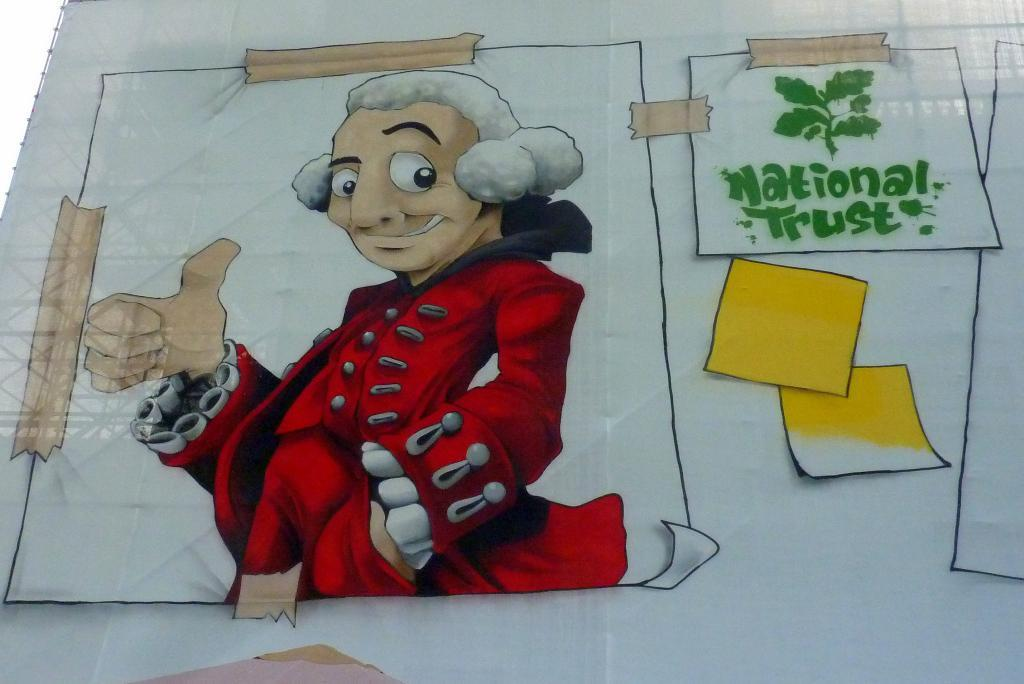<image>
Offer a succinct explanation of the picture presented. A fake poster stating National Trust next to a man in red. 